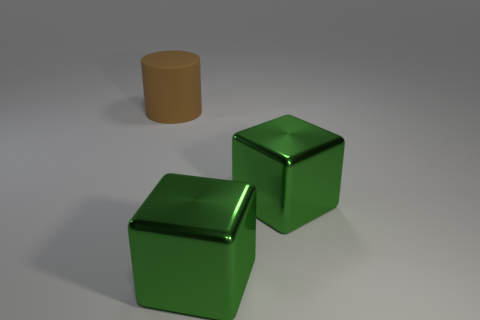Add 1 rubber cylinders. How many objects exist? 4 Subtract all cubes. How many objects are left? 1 Subtract 0 cyan cylinders. How many objects are left? 3 Subtract all large brown cylinders. Subtract all big cylinders. How many objects are left? 1 Add 1 cylinders. How many cylinders are left? 2 Add 3 big red shiny cylinders. How many big red shiny cylinders exist? 3 